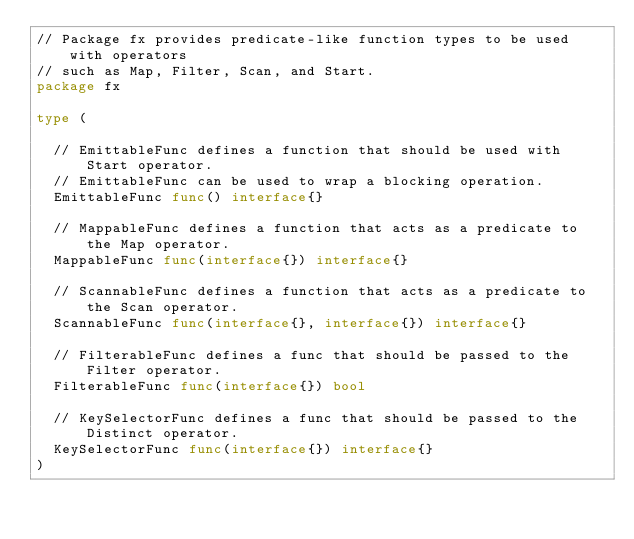<code> <loc_0><loc_0><loc_500><loc_500><_Go_>// Package fx provides predicate-like function types to be used with operators
// such as Map, Filter, Scan, and Start.
package fx

type (

	// EmittableFunc defines a function that should be used with Start operator.
	// EmittableFunc can be used to wrap a blocking operation.
	EmittableFunc func() interface{}

	// MappableFunc defines a function that acts as a predicate to the Map operator.
	MappableFunc func(interface{}) interface{}

	// ScannableFunc defines a function that acts as a predicate to the Scan operator.
	ScannableFunc func(interface{}, interface{}) interface{}

	// FilterableFunc defines a func that should be passed to the Filter operator.
	FilterableFunc func(interface{}) bool

	// KeySelectorFunc defines a func that should be passed to the Distinct operator.
	KeySelectorFunc func(interface{}) interface{}
)
</code> 